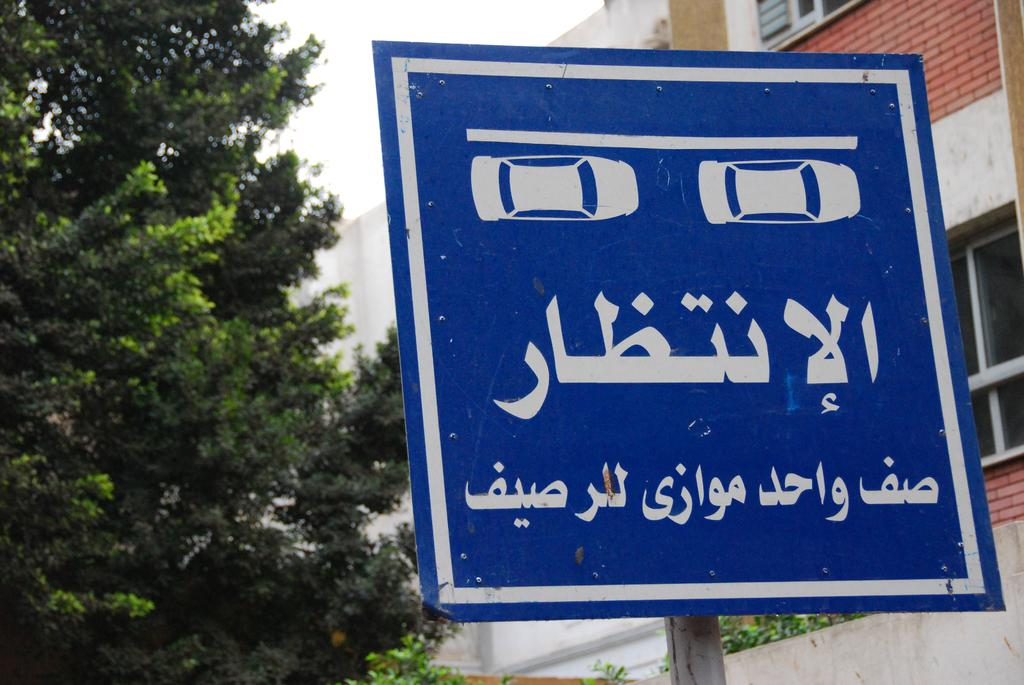What is attached to the pole in the image? There is a blue board attached to a pole in the image. What can be seen in the background of the image? There is a building, trees, and the sky visible in the background of the image. What color is the building in the image? The building is white. What color are the trees in the image? The trees are green. What color is the sky in the image? The sky is white. Where is the gold stove located in the image? There is no gold stove present in the image. What type of field can be seen in the image? There is no field visible in the image. 